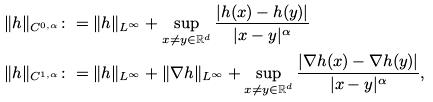<formula> <loc_0><loc_0><loc_500><loc_500>& \| h \| _ { C ^ { 0 , \alpha } } \colon = \| h \| _ { L ^ { \infty } } + \sup _ { x \neq y \in \mathbb { R } ^ { d } } \frac { | h ( x ) - h ( y ) | } { | x - y | ^ { \alpha } } \\ & \| h \| _ { C ^ { 1 , \alpha } } \colon = \| h \| _ { L ^ { \infty } } + \| \nabla h \| _ { L ^ { \infty } } + \sup _ { x \neq y \in \mathbb { R } ^ { d } } \frac { | \nabla h ( x ) - \nabla h ( y ) | } { | x - y | ^ { \alpha } } ,</formula> 